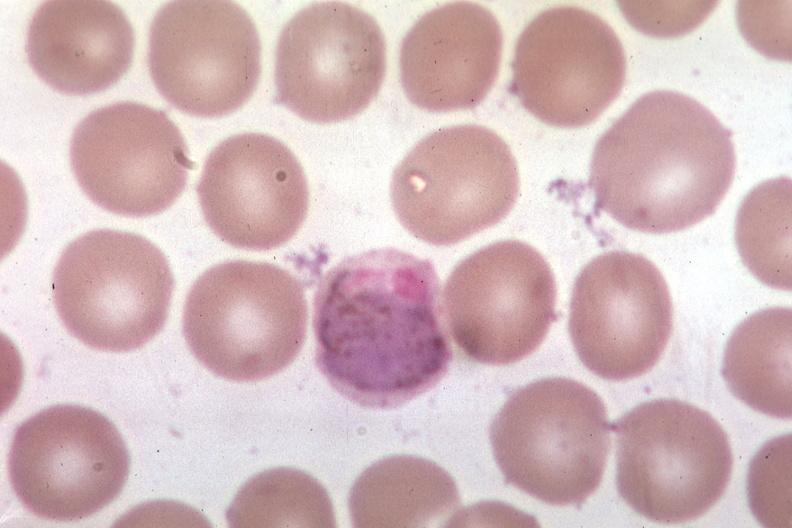does omphalocele show oil wrights?
Answer the question using a single word or phrase. No 